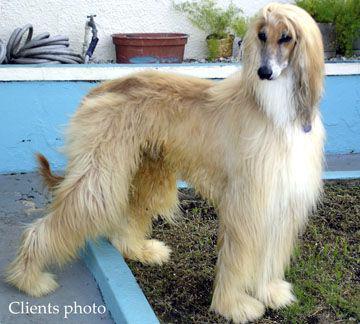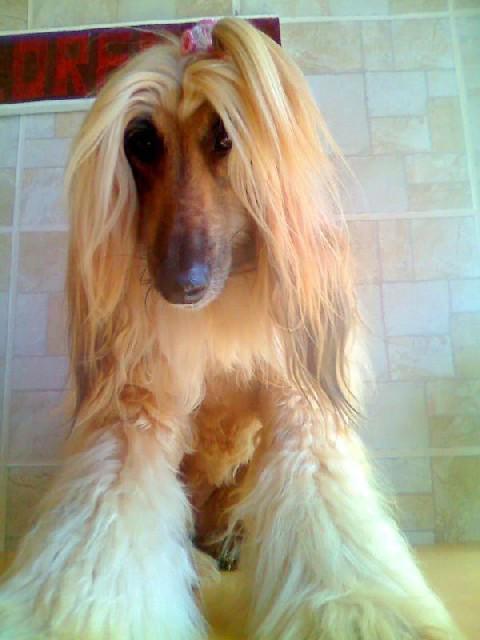The first image is the image on the left, the second image is the image on the right. For the images shown, is this caption "One image shows a dog underwater and sideways, with its head to the left and its long fur trailing rightward." true? Answer yes or no. No. The first image is the image on the left, the second image is the image on the right. Given the left and right images, does the statement "A dog is completely submerged in the water." hold true? Answer yes or no. No. 